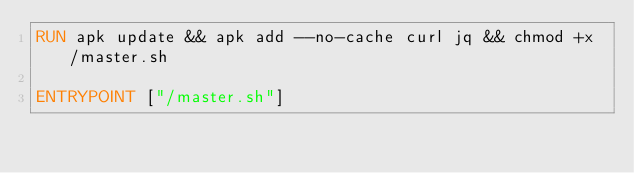<code> <loc_0><loc_0><loc_500><loc_500><_Dockerfile_>RUN apk update && apk add --no-cache curl jq && chmod +x /master.sh

ENTRYPOINT ["/master.sh"]
</code> 